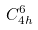<formula> <loc_0><loc_0><loc_500><loc_500>C _ { 4 h } ^ { 6 }</formula> 